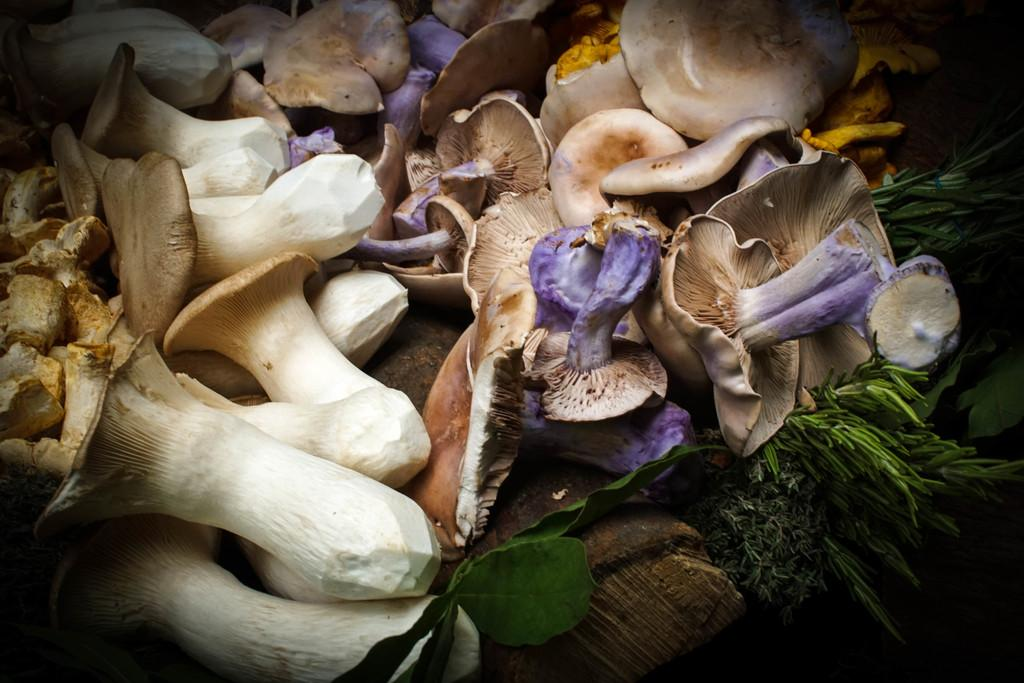What type of fungi can be seen in the image? There are mushrooms in the image. What type of current is flowing through the guitar in the image? There is no guitar present in the image, and therefore no current can be observed. 